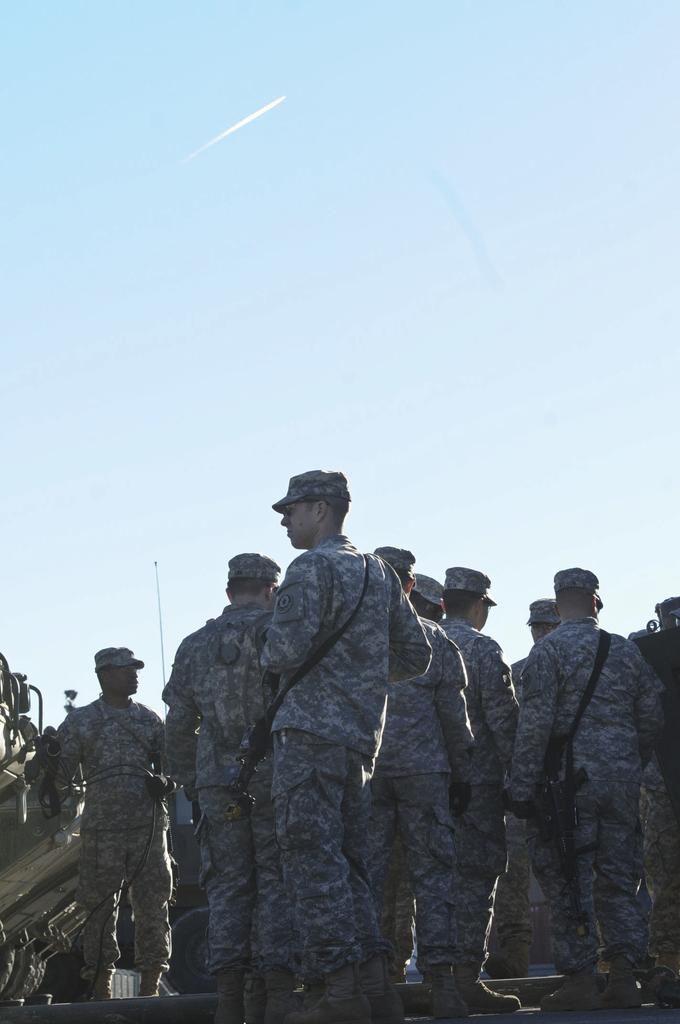How would you summarize this image in a sentence or two? In this picture we can see a group of men wore caps and holding guns with their hands and in the background we can see sky. 